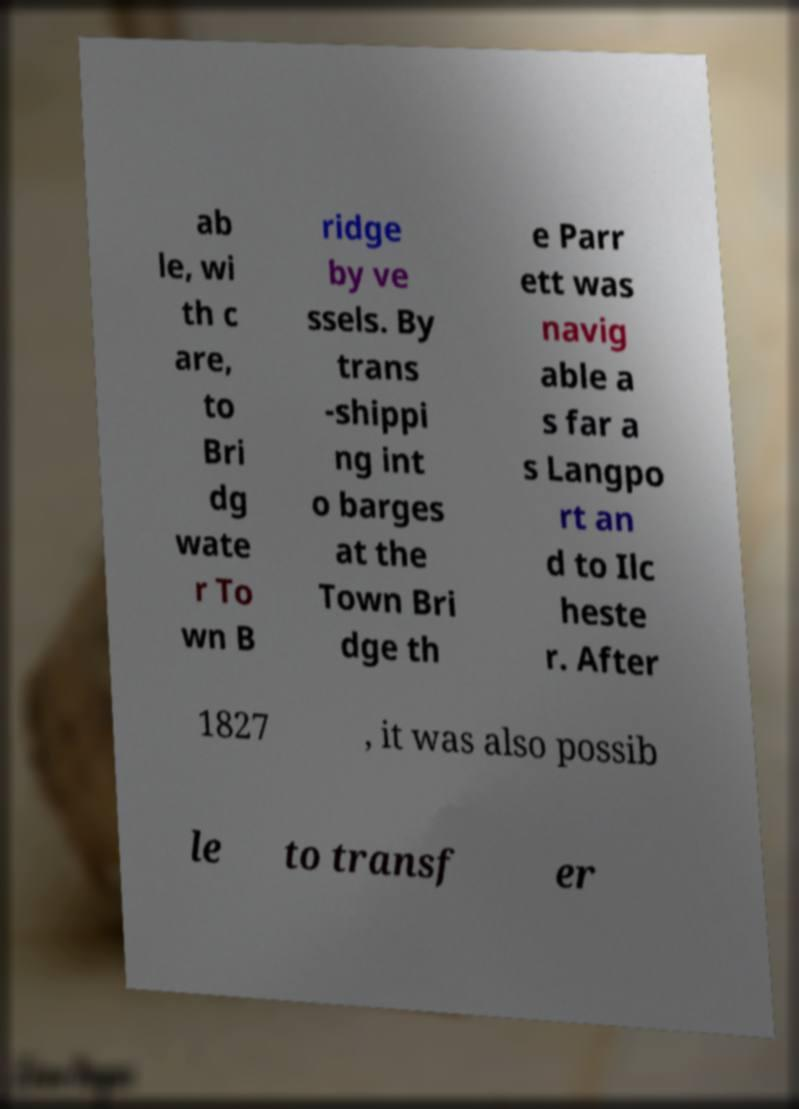Please read and relay the text visible in this image. What does it say? ab le, wi th c are, to Bri dg wate r To wn B ridge by ve ssels. By trans -shippi ng int o barges at the Town Bri dge th e Parr ett was navig able a s far a s Langpo rt an d to Ilc heste r. After 1827 , it was also possib le to transf er 